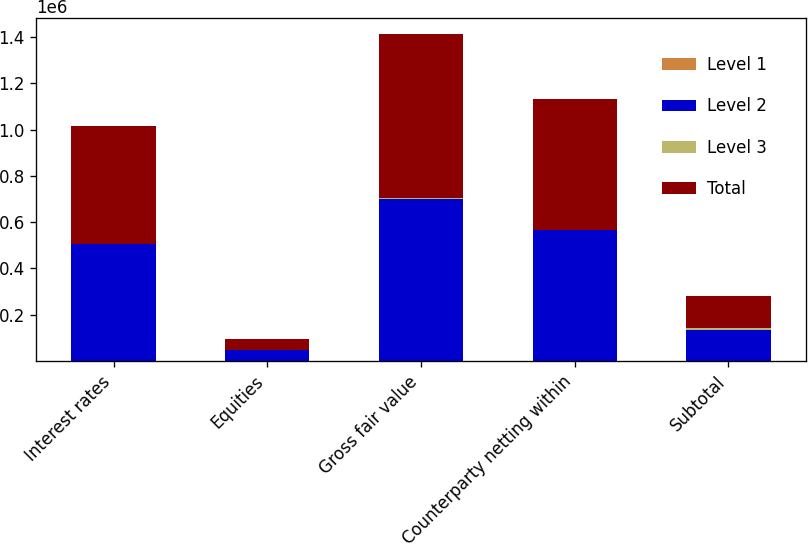<chart> <loc_0><loc_0><loc_500><loc_500><stacked_bar_chart><ecel><fcel>Interest rates<fcel>Equities<fcel>Gross fair value<fcel>Counterparty netting within<fcel>Subtotal<nl><fcel>Level 1<fcel>46<fcel>1<fcel>47<fcel>12<fcel>35<nl><fcel>Level 2<fcel>506818<fcel>47667<fcel>699585<fcel>564100<fcel>135485<nl><fcel>Level 3<fcel>614<fcel>424<fcel>6607<fcel>1417<fcel>5190<nl><fcel>Total<fcel>507478<fcel>48092<fcel>706239<fcel>565529<fcel>140710<nl></chart> 